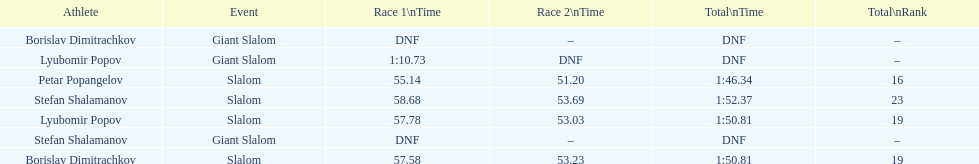Which sportsman clocked a race duration over 1:00? Lyubomir Popov. 